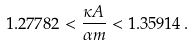Convert formula to latex. <formula><loc_0><loc_0><loc_500><loc_500>1 . 2 7 7 8 2 < \frac { \kappa A } { \alpha m } < 1 . 3 5 9 1 4 \, .</formula> 